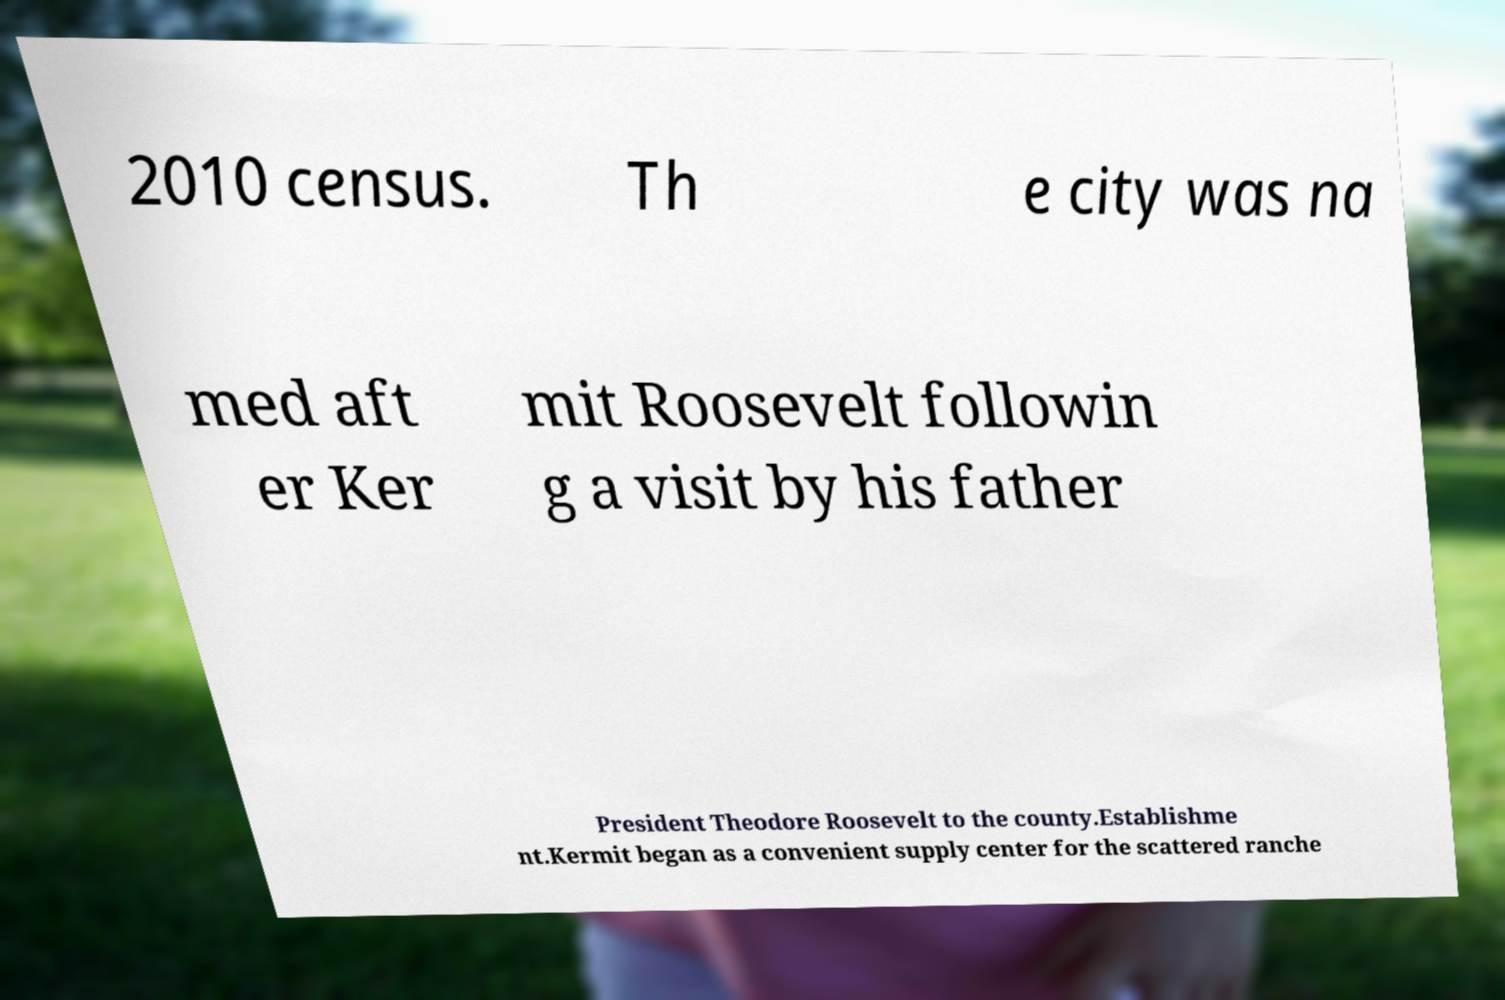Can you accurately transcribe the text from the provided image for me? 2010 census. Th e city was na med aft er Ker mit Roosevelt followin g a visit by his father President Theodore Roosevelt to the county.Establishme nt.Kermit began as a convenient supply center for the scattered ranche 